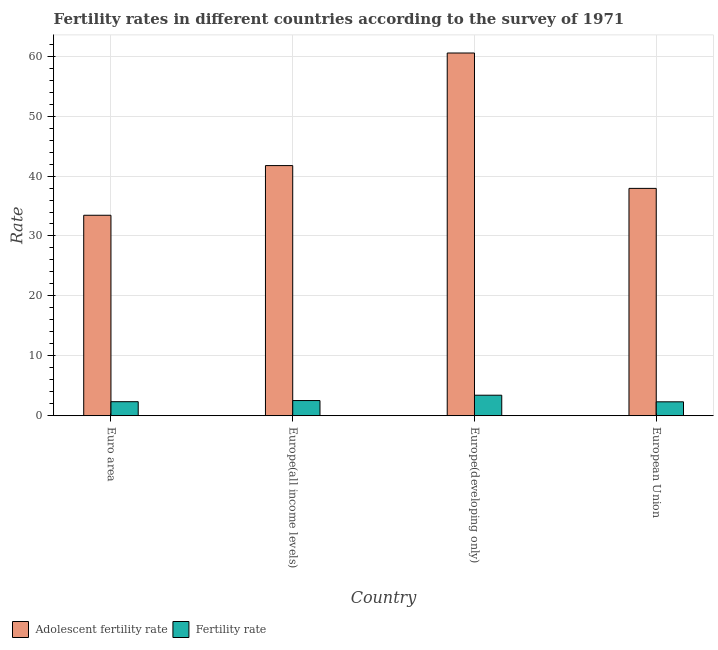How many different coloured bars are there?
Give a very brief answer. 2. Are the number of bars per tick equal to the number of legend labels?
Give a very brief answer. Yes. Are the number of bars on each tick of the X-axis equal?
Keep it short and to the point. Yes. How many bars are there on the 4th tick from the left?
Your response must be concise. 2. What is the label of the 1st group of bars from the left?
Give a very brief answer. Euro area. What is the adolescent fertility rate in Euro area?
Your answer should be compact. 33.46. Across all countries, what is the maximum adolescent fertility rate?
Your answer should be compact. 60.54. Across all countries, what is the minimum fertility rate?
Your answer should be very brief. 2.32. In which country was the adolescent fertility rate maximum?
Keep it short and to the point. Europe(developing only). What is the total fertility rate in the graph?
Ensure brevity in your answer.  10.62. What is the difference between the adolescent fertility rate in Euro area and that in European Union?
Provide a succinct answer. -4.49. What is the difference between the fertility rate in Euro area and the adolescent fertility rate in European Union?
Provide a short and direct response. -35.6. What is the average fertility rate per country?
Give a very brief answer. 2.66. What is the difference between the adolescent fertility rate and fertility rate in European Union?
Provide a succinct answer. 35.62. What is the ratio of the fertility rate in Europe(all income levels) to that in Europe(developing only)?
Ensure brevity in your answer.  0.74. Is the difference between the adolescent fertility rate in Euro area and European Union greater than the difference between the fertility rate in Euro area and European Union?
Your answer should be very brief. No. What is the difference between the highest and the second highest fertility rate?
Provide a succinct answer. 0.89. What is the difference between the highest and the lowest adolescent fertility rate?
Offer a terse response. 27.08. In how many countries, is the adolescent fertility rate greater than the average adolescent fertility rate taken over all countries?
Offer a very short reply. 1. Is the sum of the adolescent fertility rate in Europe(all income levels) and Europe(developing only) greater than the maximum fertility rate across all countries?
Make the answer very short. Yes. What does the 1st bar from the left in Euro area represents?
Provide a succinct answer. Adolescent fertility rate. What does the 1st bar from the right in Europe(developing only) represents?
Offer a very short reply. Fertility rate. How many countries are there in the graph?
Keep it short and to the point. 4. What is the difference between two consecutive major ticks on the Y-axis?
Provide a succinct answer. 10. Does the graph contain any zero values?
Your answer should be compact. No. Does the graph contain grids?
Provide a short and direct response. Yes. Where does the legend appear in the graph?
Your answer should be compact. Bottom left. How are the legend labels stacked?
Make the answer very short. Horizontal. What is the title of the graph?
Keep it short and to the point. Fertility rates in different countries according to the survey of 1971. What is the label or title of the X-axis?
Your answer should be compact. Country. What is the label or title of the Y-axis?
Your response must be concise. Rate. What is the Rate of Adolescent fertility rate in Euro area?
Provide a succinct answer. 33.46. What is the Rate in Fertility rate in Euro area?
Ensure brevity in your answer.  2.34. What is the Rate of Adolescent fertility rate in Europe(all income levels)?
Offer a very short reply. 41.75. What is the Rate of Fertility rate in Europe(all income levels)?
Provide a short and direct response. 2.53. What is the Rate in Adolescent fertility rate in Europe(developing only)?
Your response must be concise. 60.54. What is the Rate in Fertility rate in Europe(developing only)?
Give a very brief answer. 3.42. What is the Rate in Adolescent fertility rate in European Union?
Your answer should be compact. 37.94. What is the Rate in Fertility rate in European Union?
Give a very brief answer. 2.32. Across all countries, what is the maximum Rate of Adolescent fertility rate?
Give a very brief answer. 60.54. Across all countries, what is the maximum Rate in Fertility rate?
Offer a terse response. 3.42. Across all countries, what is the minimum Rate in Adolescent fertility rate?
Make the answer very short. 33.46. Across all countries, what is the minimum Rate of Fertility rate?
Your answer should be compact. 2.32. What is the total Rate in Adolescent fertility rate in the graph?
Provide a short and direct response. 173.69. What is the total Rate in Fertility rate in the graph?
Provide a succinct answer. 10.62. What is the difference between the Rate of Adolescent fertility rate in Euro area and that in Europe(all income levels)?
Make the answer very short. -8.29. What is the difference between the Rate in Fertility rate in Euro area and that in Europe(all income levels)?
Give a very brief answer. -0.19. What is the difference between the Rate of Adolescent fertility rate in Euro area and that in Europe(developing only)?
Offer a very short reply. -27.08. What is the difference between the Rate in Fertility rate in Euro area and that in Europe(developing only)?
Your response must be concise. -1.08. What is the difference between the Rate of Adolescent fertility rate in Euro area and that in European Union?
Keep it short and to the point. -4.49. What is the difference between the Rate of Fertility rate in Euro area and that in European Union?
Keep it short and to the point. 0.02. What is the difference between the Rate of Adolescent fertility rate in Europe(all income levels) and that in Europe(developing only)?
Your answer should be compact. -18.79. What is the difference between the Rate of Fertility rate in Europe(all income levels) and that in Europe(developing only)?
Offer a very short reply. -0.89. What is the difference between the Rate of Adolescent fertility rate in Europe(all income levels) and that in European Union?
Offer a terse response. 3.8. What is the difference between the Rate in Fertility rate in Europe(all income levels) and that in European Union?
Offer a terse response. 0.21. What is the difference between the Rate in Adolescent fertility rate in Europe(developing only) and that in European Union?
Provide a short and direct response. 22.59. What is the difference between the Rate in Fertility rate in Europe(developing only) and that in European Union?
Offer a terse response. 1.1. What is the difference between the Rate of Adolescent fertility rate in Euro area and the Rate of Fertility rate in Europe(all income levels)?
Your answer should be very brief. 30.92. What is the difference between the Rate of Adolescent fertility rate in Euro area and the Rate of Fertility rate in Europe(developing only)?
Make the answer very short. 30.03. What is the difference between the Rate of Adolescent fertility rate in Euro area and the Rate of Fertility rate in European Union?
Your answer should be very brief. 31.14. What is the difference between the Rate in Adolescent fertility rate in Europe(all income levels) and the Rate in Fertility rate in Europe(developing only)?
Provide a succinct answer. 38.33. What is the difference between the Rate of Adolescent fertility rate in Europe(all income levels) and the Rate of Fertility rate in European Union?
Give a very brief answer. 39.43. What is the difference between the Rate in Adolescent fertility rate in Europe(developing only) and the Rate in Fertility rate in European Union?
Provide a succinct answer. 58.21. What is the average Rate in Adolescent fertility rate per country?
Your answer should be compact. 43.42. What is the average Rate in Fertility rate per country?
Make the answer very short. 2.66. What is the difference between the Rate of Adolescent fertility rate and Rate of Fertility rate in Euro area?
Ensure brevity in your answer.  31.12. What is the difference between the Rate in Adolescent fertility rate and Rate in Fertility rate in Europe(all income levels)?
Keep it short and to the point. 39.21. What is the difference between the Rate in Adolescent fertility rate and Rate in Fertility rate in Europe(developing only)?
Ensure brevity in your answer.  57.11. What is the difference between the Rate in Adolescent fertility rate and Rate in Fertility rate in European Union?
Give a very brief answer. 35.62. What is the ratio of the Rate in Adolescent fertility rate in Euro area to that in Europe(all income levels)?
Give a very brief answer. 0.8. What is the ratio of the Rate in Fertility rate in Euro area to that in Europe(all income levels)?
Offer a very short reply. 0.92. What is the ratio of the Rate of Adolescent fertility rate in Euro area to that in Europe(developing only)?
Keep it short and to the point. 0.55. What is the ratio of the Rate in Fertility rate in Euro area to that in Europe(developing only)?
Keep it short and to the point. 0.68. What is the ratio of the Rate of Adolescent fertility rate in Euro area to that in European Union?
Provide a short and direct response. 0.88. What is the ratio of the Rate of Fertility rate in Euro area to that in European Union?
Offer a terse response. 1.01. What is the ratio of the Rate in Adolescent fertility rate in Europe(all income levels) to that in Europe(developing only)?
Your answer should be very brief. 0.69. What is the ratio of the Rate of Fertility rate in Europe(all income levels) to that in Europe(developing only)?
Your answer should be very brief. 0.74. What is the ratio of the Rate of Adolescent fertility rate in Europe(all income levels) to that in European Union?
Your answer should be compact. 1.1. What is the ratio of the Rate in Fertility rate in Europe(all income levels) to that in European Union?
Make the answer very short. 1.09. What is the ratio of the Rate in Adolescent fertility rate in Europe(developing only) to that in European Union?
Offer a terse response. 1.6. What is the ratio of the Rate of Fertility rate in Europe(developing only) to that in European Union?
Offer a terse response. 1.47. What is the difference between the highest and the second highest Rate of Adolescent fertility rate?
Keep it short and to the point. 18.79. What is the difference between the highest and the second highest Rate in Fertility rate?
Offer a very short reply. 0.89. What is the difference between the highest and the lowest Rate in Adolescent fertility rate?
Make the answer very short. 27.08. What is the difference between the highest and the lowest Rate in Fertility rate?
Keep it short and to the point. 1.1. 